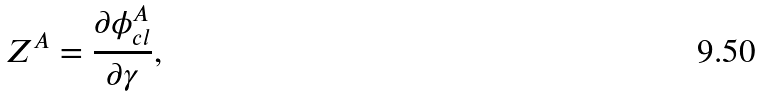Convert formula to latex. <formula><loc_0><loc_0><loc_500><loc_500>Z ^ { A } = \frac { \partial \phi _ { c l } ^ { A } } { \partial \gamma } ,</formula> 